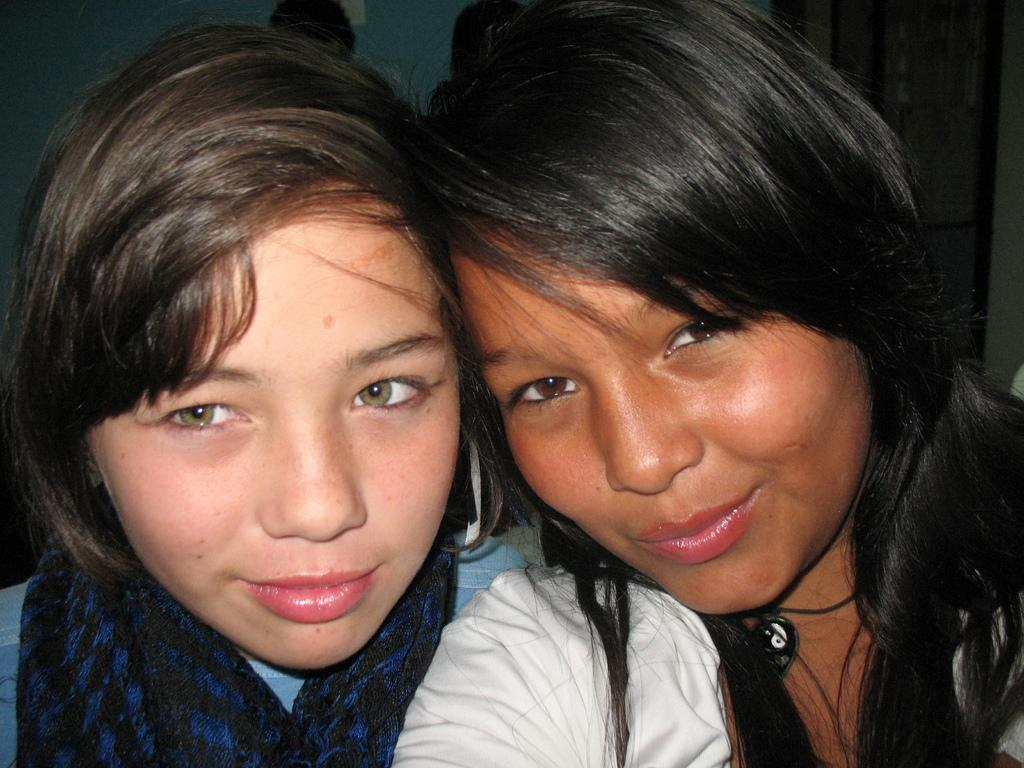How many people are in the image? There are two women in the image. What can be seen in the background of the image? There is a wall in the background of the image. What type of tub is visible in the image? There is no tub present in the image. What advice might the women's grandmother give them in the image? There is no grandmother present in the image, so it is not possible to determine what advice she might give. 